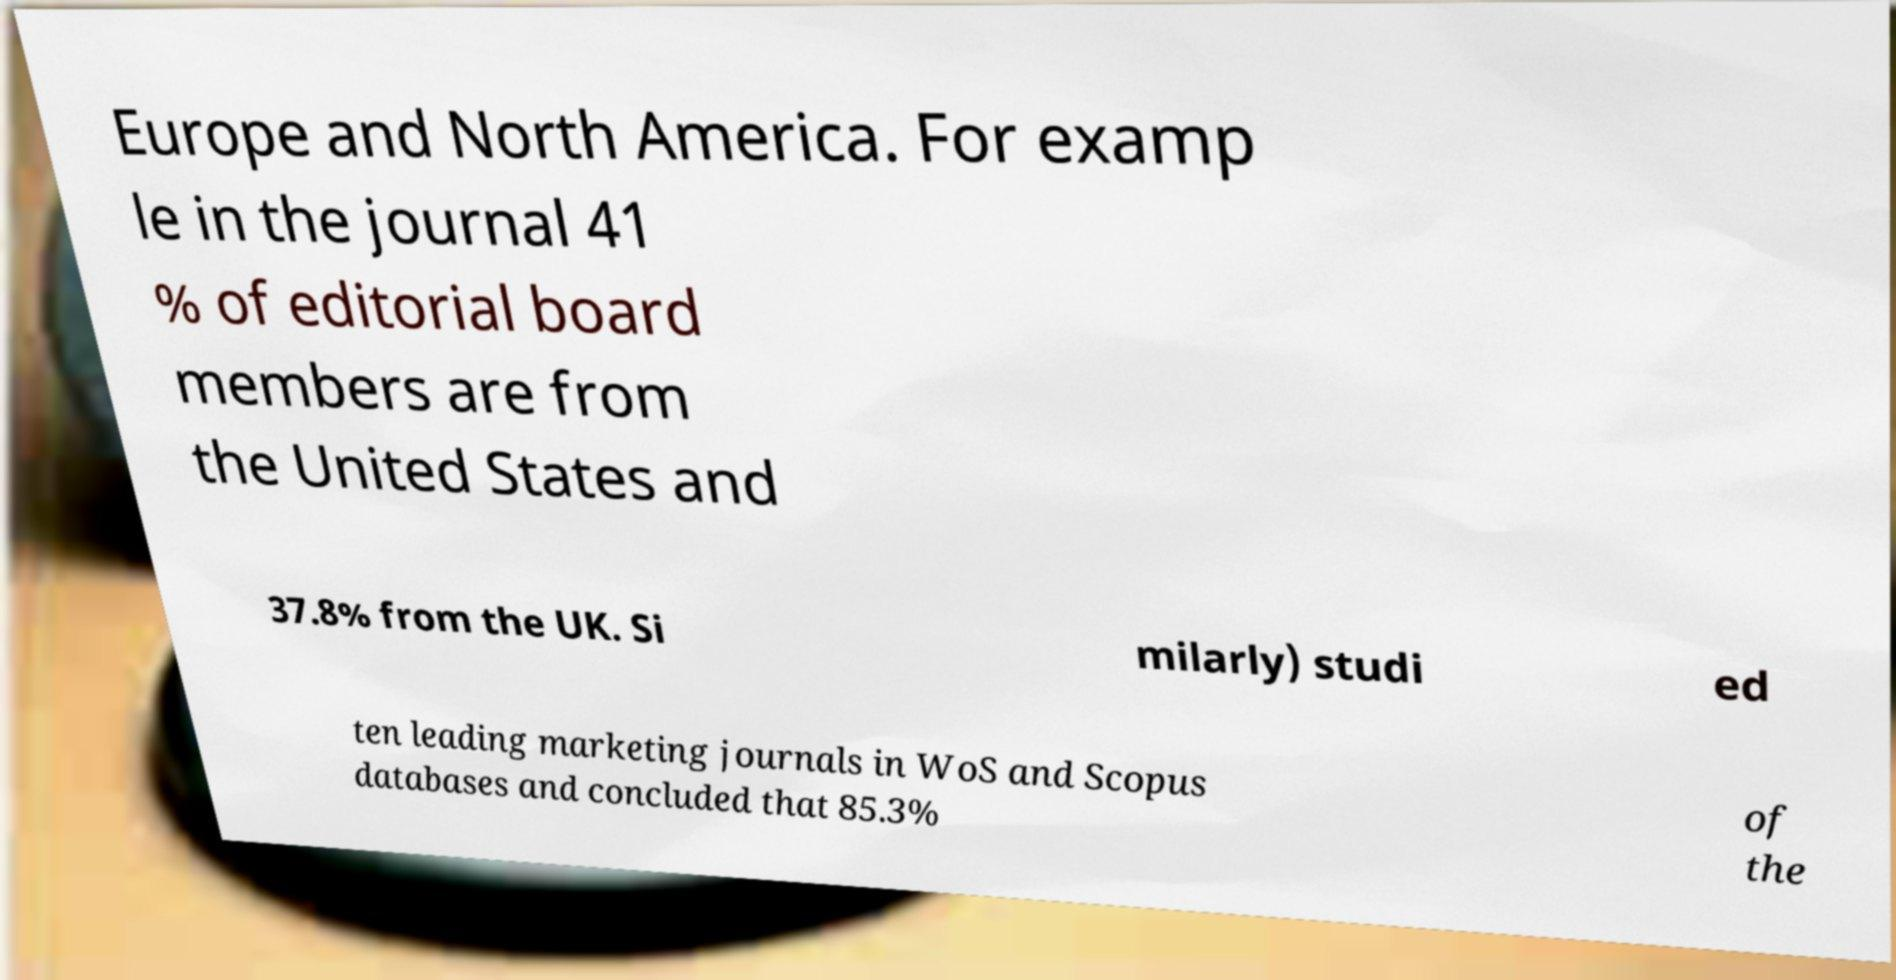Could you assist in decoding the text presented in this image and type it out clearly? Europe and North America. For examp le in the journal 41 % of editorial board members are from the United States and 37.8% from the UK. Si milarly) studi ed ten leading marketing journals in WoS and Scopus databases and concluded that 85.3% of the 